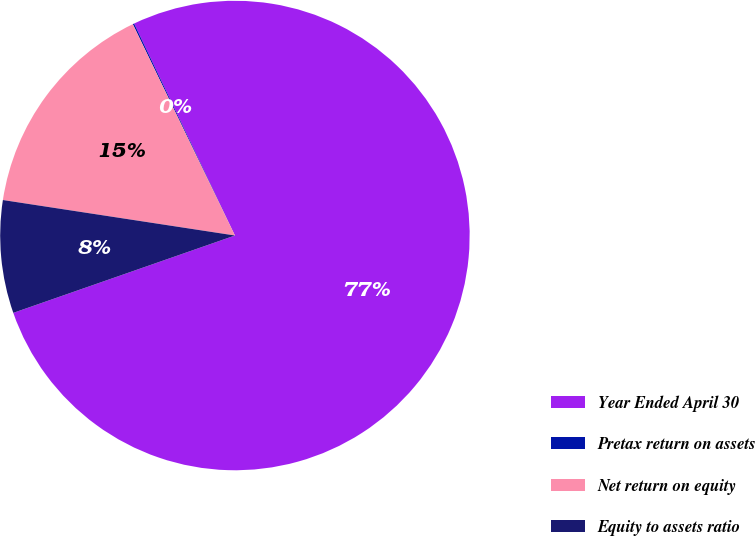<chart> <loc_0><loc_0><loc_500><loc_500><pie_chart><fcel>Year Ended April 30<fcel>Pretax return on assets<fcel>Net return on equity<fcel>Equity to assets ratio<nl><fcel>76.72%<fcel>0.1%<fcel>15.42%<fcel>7.76%<nl></chart> 